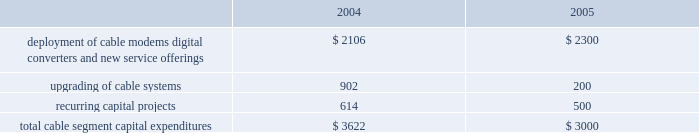Management 2019s discussion and analysis of financial condition and results of operations comcast corporation and subsidiaries28 comcast corporation and subsidiaries the exchangeable notes varies based upon the fair market value of the security to which it is indexed .
The exchangeable notes are collateralized by our investments in cablevision , microsoft and vodafone , respectively .
The comcast exchangeable notes are collateralized by our class a special common stock held in treasury .
We have settled and intend in the future to settle all of the comcast exchangeable notes using cash .
During 2004 and 2003 , we settled an aggregate of $ 847 million face amount and $ 638 million face amount , respectively , of our obligations relating to our notes exchangeable into comcast stock by delivering cash to the counterparty upon maturity of the instruments , and the equity collar agreements related to the underlying shares expired or were settled .
During 2004 and 2003 , we settled $ 2.359 billion face amount and $ 1.213 billion face amount , respectively , of our obligations relating to our exchangeable notes by delivering the underlying shares of common stock to the counterparty upon maturity of the investments .
As of december 31 , 2004 , our debt includes an aggregate of $ 1.699 billion of exchangeable notes , including $ 1.645 billion within current portion of long-term debt .
As of december 31 , 2004 , the securities we hold collateralizing the exchangeable notes were sufficient to substantially satisfy the debt obligations associated with the outstanding exchangeable notes .
Stock repurchases .
During 2004 , under our board-authorized , $ 2 billion share repurchase program , we repurchased 46.9 million shares of our class a special common stock for $ 1.328 billion .
We expect such repurchases to continue from time to time in the open market or in private transactions , subject to market conditions .
Refer to notes 8 and 10 to our consolidated financial statements for a discussion of our financing activities .
Investing activities net cash used in investing activities from continuing operations was $ 4.512 billion for the year ended december 31 , 2004 , and consists primarily of capital expenditures of $ 3.660 billion , additions to intangible and other noncurrent assets of $ 628 million and the acquisition of techtv for approximately $ 300 million .
Capital expenditures .
Our most significant recurring investing activity has been and is expected to continue to be capital expendi- tures .
The table illustrates the capital expenditures we incurred in our cable segment during 2004 and expect to incur in 2005 ( dollars in millions ) : .
The amount of our capital expenditures for 2005 and for subsequent years will depend on numerous factors , some of which are beyond our control , including competition , changes in technology and the timing and rate of deployment of new services .
Additions to intangibles .
Additions to intangibles during 2004 primarily relate to our investment in a $ 250 million long-term strategic license agreement with gemstar , multiple dwelling unit contracts of approximately $ 133 million and other licenses and software intangibles of approximately $ 168 million .
Investments .
Proceeds from sales , settlements and restructurings of investments totaled $ 228 million during 2004 , related to the sales of our non-strategic investments , including our 20% ( 20 % ) interest in dhc ventures , llc ( discovery health channel ) for approximately $ 149 million .
We consider investments that we determine to be non-strategic , highly-valued , or both to be a source of liquidity .
We consider our investment in $ 1.5 billion in time warner common-equivalent preferred stock to be an anticipated source of liquidity .
We do not have any significant contractual funding commitments with respect to any of our investments .
Refer to notes 6 and 7 to our consolidated financial statements for a discussion of our investments and our intangible assets , respectively .
Off-balance sheet arrangements we do not have any significant off-balance sheet arrangements that are reasonably likely to have a current or future effect on our financial condition , results of operations , liquidity , capital expenditures or capital resources. .
What percentage of total cable segment capital expenditures in 2005 where due to upgrading of cable systems? 
Computations: (200 / 3000)
Answer: 0.06667. 